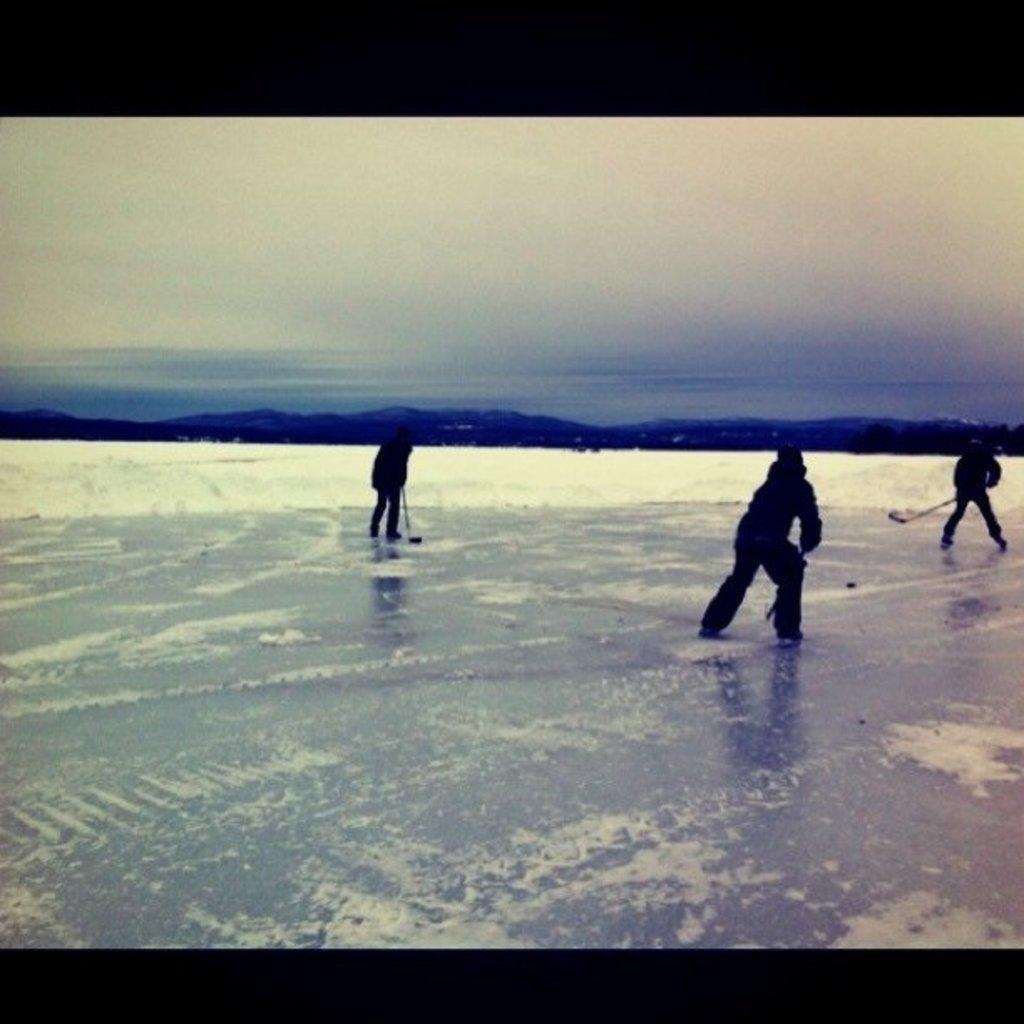What sport are the three persons playing in the image? The three persons are playing ice hockey in the image. What is the weather like in the image? There is snow visible in the image, indicating a cold and likely snowy environment. What can be seen in the background of the image? There are mountains in the background of the image. What is visible at the top of the image? The sky is visible at the top of the image. What type of tin is being exchanged between the ice hockey players in the image? There is no tin being exchanged between the ice hockey players in the image. The players are focused on playing the sport and not engaging in any exchanges. 